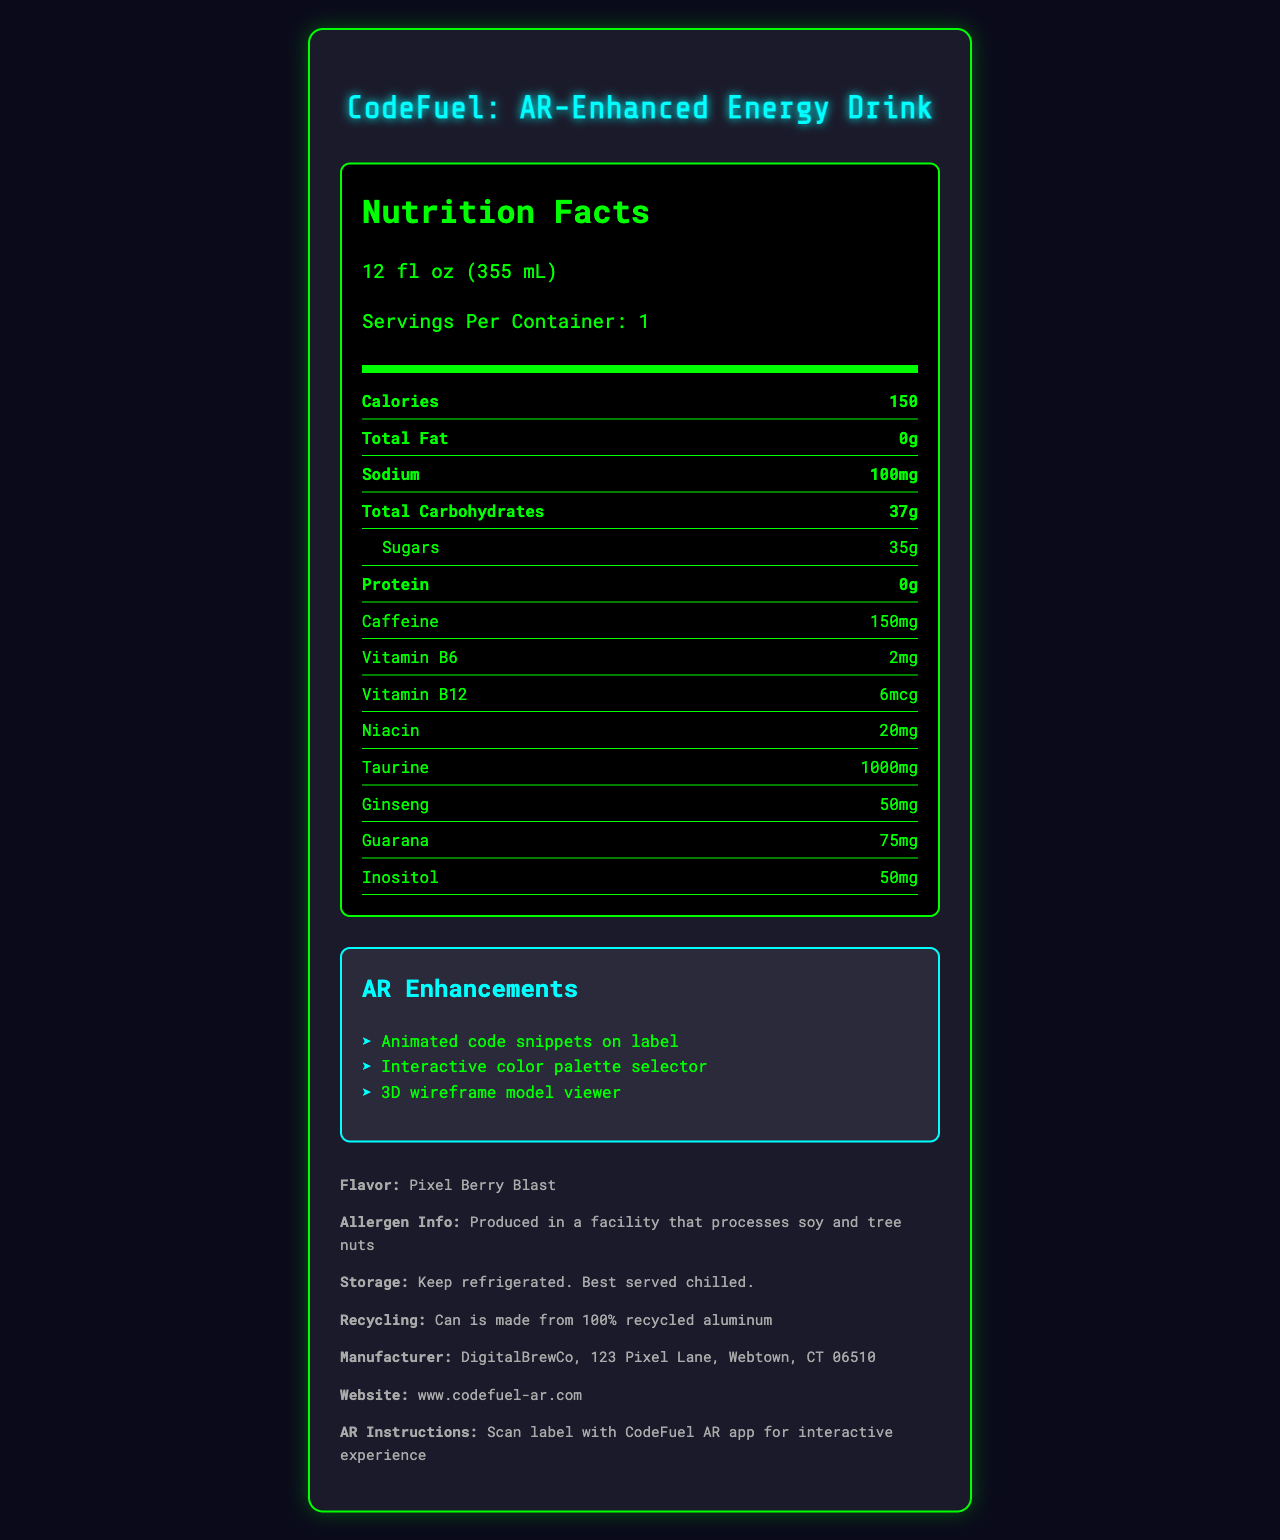what is the serving size? The serving size is clearly indicated as 12 fl oz (355 mL) in the Nutrition Facts section.
Answer: 12 fl oz (355 mL) how many calories are there per serving? The document states that there are 150 calories per serving.
Answer: 150 how much sugar does the product contain? The amount of sugar is given as 35g in the Nutrition Facts section.
Answer: 35g how much caffeine is in this energy drink? The caffeine content is stated as 150mg.
Answer: 150mg which vitamins are included in the energy drink? The document lists Vitamin B6 (2mg), Vitamin B12 (6mcg), and Niacin (20mg) under the nutritional information.
Answer: Vitamin B6, Vitamin B12, and Niacin what flavor is the energy drink? The flavor profile is specified as Pixel Berry Blast in the additional information section.
Answer: Pixel Berry Blast where is the manufacturer located? The document lists the manufacturer's information as DigitalBrewCo, 123 Pixel Lane, Webtown, CT 06510.
Answer: DigitalBrewCo, 123 Pixel Lane, Webtown, CT 06510 what should you do to access the AR features? The scan instructions indicate that you need to scan the label with the CodeFuel AR app for the interactive experience.
Answer: Scan the label with the CodeFuel AR app how much sodium does the drink contain? Sodium content is listed as 100mg in the Nutrition Facts section.
Answer: 100mg which of the following is NOT an AR enhancement feature? A. Animated code snippets on label B. Virtual reality headset C. 3D wireframe model viewer D. Interactive color palette selector The AR enhancements listed are "Animated code snippets on label," "Interactive color palette selector," and "3D wireframe model viewer." Virtual reality headset is not mentioned.
Answer: B what is the total carbohydrate content? A. 35g B. 37g C. 100g D. 50g The total carbohydrate content is given as 37g in the Nutrition Facts section.
Answer: B is the product gluten-free? The document does not provide any information regarding gluten content.
Answer: Not enough information what are the storage instructions? The storage instructions are mentioned as "Keep refrigerated. Best served chilled."
Answer: Keep refrigerated. Best served chilled. what is the main design theme of the product label? The main design elements include binary code background, neon circuit board patterns, and floating UI elements, all related to coding and technology.
Answer: Coding and technology is the can made from recycled materials? The document specifies that the can is made from 100% recycled aluminum.
Answer: Yes how many servings are in one container? The document states that there is 1 serving per container.
Answer: 1 describe the main idea of the document The nutrition facts label provides details about the product's serving size, calories, fat, sodium, carbohydrates, sugars, protein, caffeine, vitamins, and other ingredients. It also highlights the AR features of the label and the design elements used. Additionally, it includes information about allergens, storage, recycling, how to access AR features, and manufacturer contact details.
Answer: The document is a nutrition facts label for "CodeFuel: AR-Enhanced Energy Drink" which contains nutritional information, AR enhancement features, flavor profile, design elements, allergen information, storage instructions, recycling info, and manufacturer details. can you list all design elements mentioned in the document? The design elements are described in the additional information section, listing binary code backgrounds, neon circuit board patterns, and floating UI elements.
Answer: Binary code background, Neon circuit board patterns, Floating UI elements what type of pattern is used in the label design? A. Polka dots B. Stripes C. Neon circuit board D. Stars The document mentions neon circuit board patterns as part of the design elements.
Answer: C 